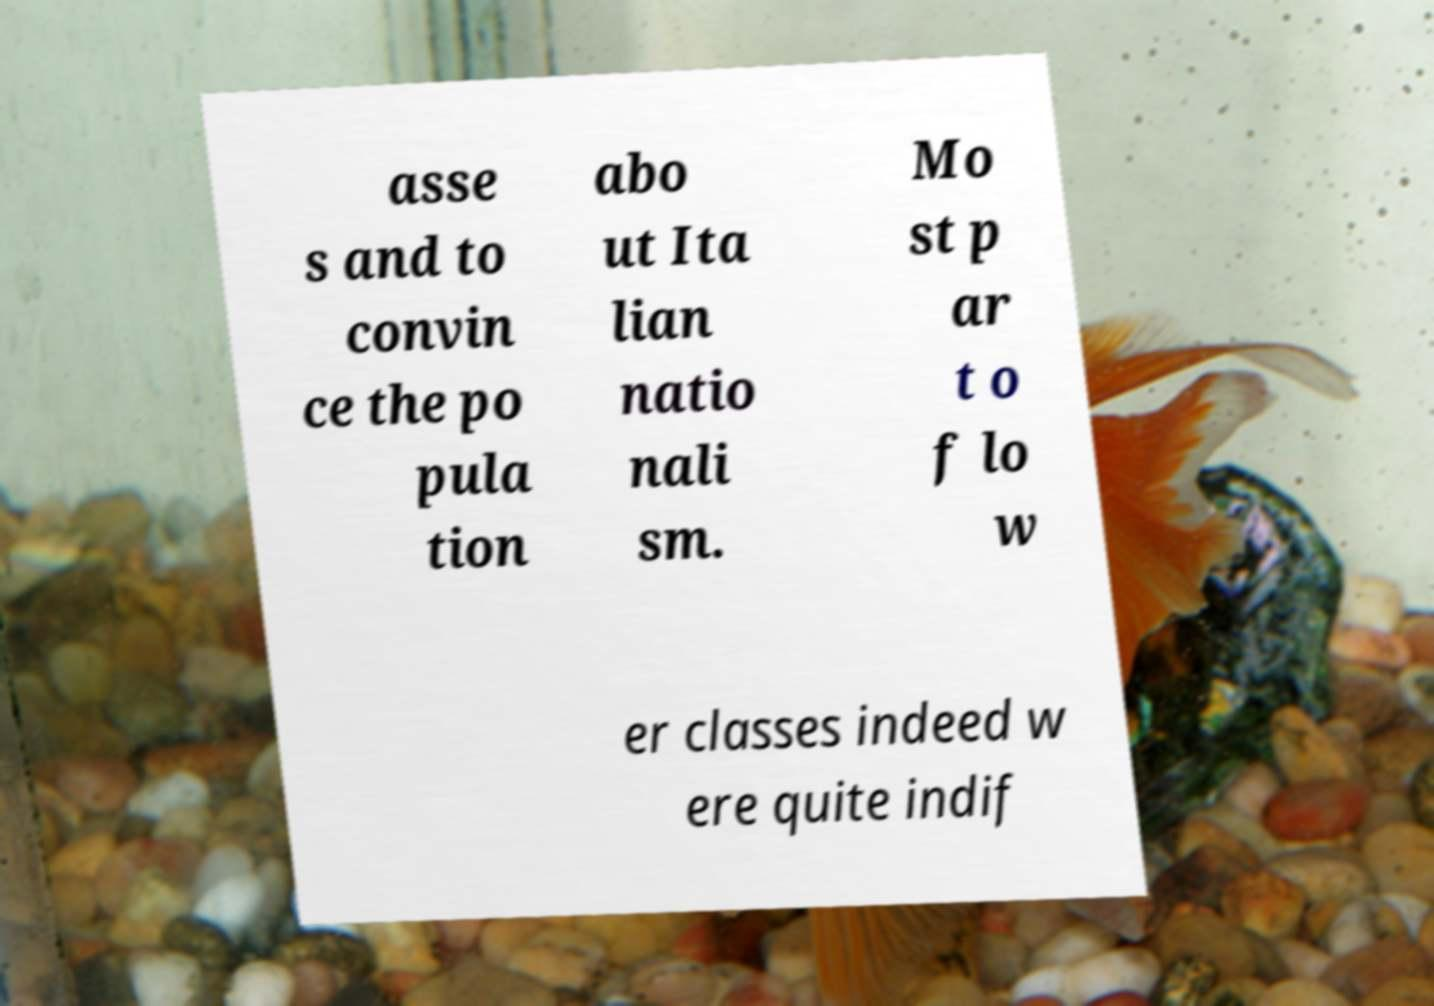There's text embedded in this image that I need extracted. Can you transcribe it verbatim? asse s and to convin ce the po pula tion abo ut Ita lian natio nali sm. Mo st p ar t o f lo w er classes indeed w ere quite indif 